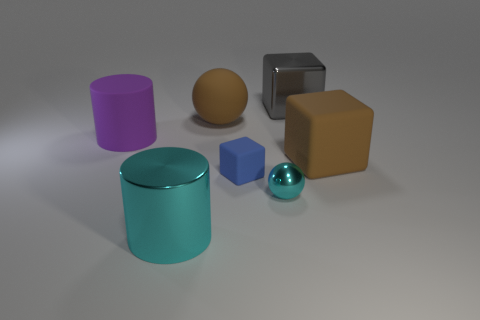Does the gray block have the same material as the big cylinder that is to the left of the large cyan thing?
Give a very brief answer. No. How many objects are large blocks or purple cylinders?
Provide a short and direct response. 3. Are there any small blue matte objects?
Your answer should be compact. Yes. What is the shape of the large brown matte thing to the right of the large shiny object that is behind the brown matte sphere?
Your answer should be very brief. Cube. How many things are brown rubber things that are right of the gray metallic object or large brown things in front of the brown matte ball?
Your response must be concise. 1. There is a cyan thing that is the same size as the blue object; what material is it?
Your response must be concise. Metal. What color is the tiny matte thing?
Give a very brief answer. Blue. What material is the object that is both behind the big purple matte cylinder and in front of the gray block?
Provide a short and direct response. Rubber. Is there a big cyan cylinder to the right of the big brown rubber object on the right side of the large cube that is behind the purple cylinder?
Provide a short and direct response. No. The cylinder that is the same color as the shiny ball is what size?
Keep it short and to the point. Large. 